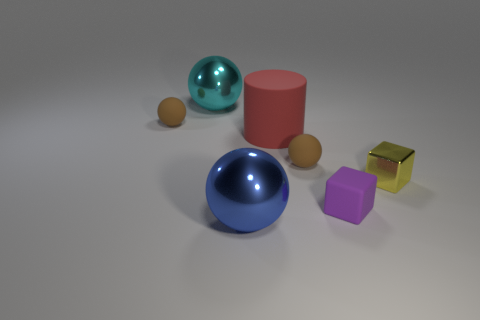Subtract all large blue spheres. How many spheres are left? 3 Add 1 blue metallic balls. How many objects exist? 8 Subtract all cyan cubes. How many brown spheres are left? 2 Add 6 purple cubes. How many purple cubes are left? 7 Add 4 large cyan matte cylinders. How many large cyan matte cylinders exist? 4 Subtract all blue spheres. How many spheres are left? 3 Subtract 0 brown cylinders. How many objects are left? 7 Subtract all cubes. How many objects are left? 5 Subtract 1 blocks. How many blocks are left? 1 Subtract all blue blocks. Subtract all gray balls. How many blocks are left? 2 